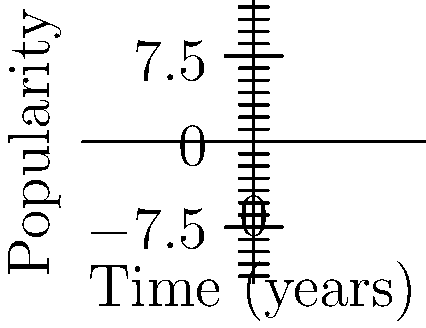Given two polynomial functions representing the popularity trends of Haiku and Sonnet poetry styles over time:

Haiku: $f(x) = -0.1x^3 + 1.5x^2 - 5x + 20$
Sonnet: $g(x) = 0.2x^2 - 2x + 10$

Where $x$ represents time in years and $f(x)$ and $g(x)$ represent popularity scores. At what point in time do these two poetry styles have equal popularity, and what is their popularity score at that point? Round your answer to two decimal places. To find the intersection point of these two polynomial curves, we need to solve the equation:

$f(x) = g(x)$

Substituting the given functions:

$-0.1x^3 + 1.5x^2 - 5x + 20 = 0.2x^2 - 2x + 10$

Rearranging the equation:

$-0.1x^3 + 1.3x^2 - 3x + 10 = 0$

This is a cubic equation that can be solved using numerical methods or a graphing calculator. Using such methods, we find that the equation has one real root at approximately $x = 5.83$.

To find the popularity score at this point, we can substitute this x-value into either of the original functions. Let's use $f(x)$:

$f(5.83) = -0.1(5.83)^3 + 1.5(5.83)^2 - 5(5.83) + 20$

$f(5.83) \approx 13.37$

Therefore, the two poetry styles have equal popularity after approximately 5.83 years, with a popularity score of about 13.37.
Answer: (5.83, 13.37) 